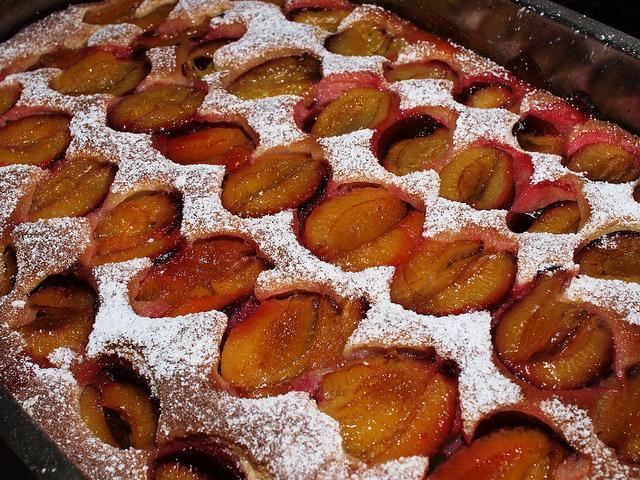How many donuts are there?
Give a very brief answer. 5. 